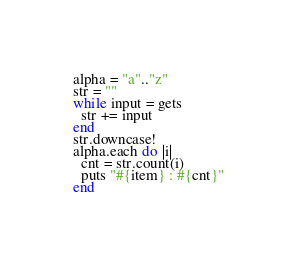Convert code to text. <code><loc_0><loc_0><loc_500><loc_500><_Ruby_>alpha = "a".."z"
str = ""
while input = gets
  str += input
end
str.downcase!
alpha.each do |i|
  cnt = str.count(i)
  puts "#{item} : #{cnt}"
end</code> 